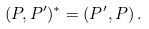<formula> <loc_0><loc_0><loc_500><loc_500>( P , P ^ { \prime } ) ^ { * } = ( P ^ { \prime } , P ) \, .</formula> 